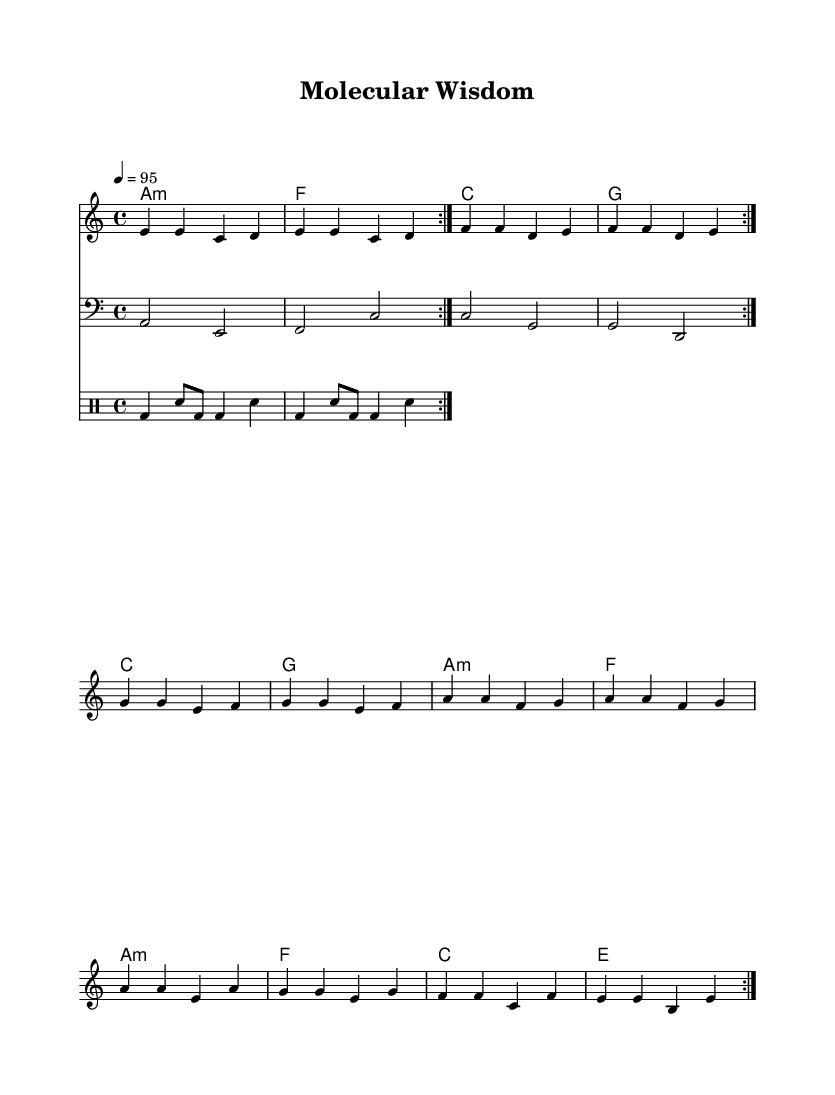What is the key signature of this music? The key signature is indicated at the beginning of the staff and shows one flat (B) which signifies A minor or C major.
Answer: A minor What is the time signature of this piece? The time signature appears at the beginning of the score and is represented by the two numbers placed one over the other. In this case, it is 4 over 4.
Answer: 4/4 What is the tempo marking for the piece? The tempo is indicated in beats per minute (BPM) in the score, showing how fast the music should be played. Here, it shows the number '95', which means quarter note equals 95 beats per minute.
Answer: 95 How many measures are in the melody section before repeating? The melody shows a repeated section indicated by the repeat sign. Counting the notes, there are 12 measures in total, which are taken twice.
Answer: 12 Which style influences are evident in this composition? The song is labeled as "Reggaeton-influenced," which can be identified by the rhythmic and stylistic elements present in the drum pattern along with the overall groove.
Answer: Reggaeton How do the lyrics relate to the themes of the music? The lyrics mention both ancient wisdom and modern scientific practices, reflecting a blend of cultural elements which map onto the harmonic and rhythmic structures of Latin music.
Answer: Cultural blend What kind of percussion pattern is utilized in the drum section? The drum pattern is written in a distinctive drum notation which features bass and snare notes in a repeating sequence that is common in Reggaeton, indicating a danceable rhythm.
Answer: Bass and snare pattern 